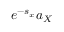<formula> <loc_0><loc_0><loc_500><loc_500>e ^ { - s _ { x } } a _ { X }</formula> 